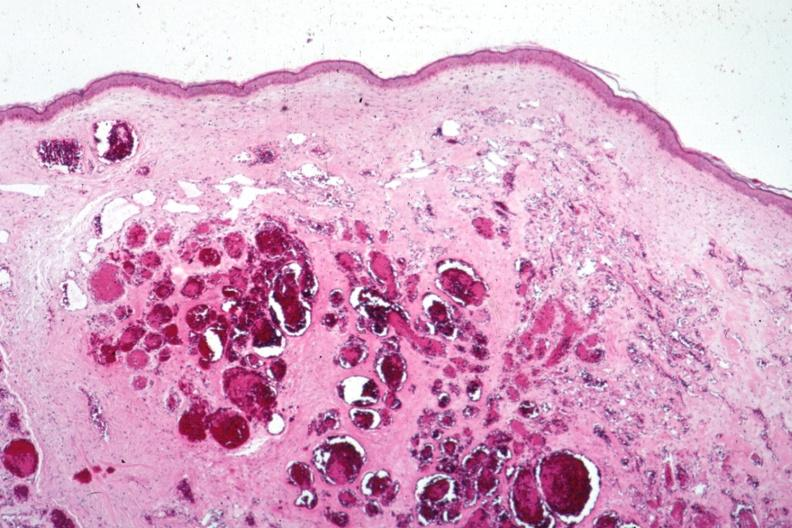what is present?
Answer the question using a single word or phrase. Hemangioma 